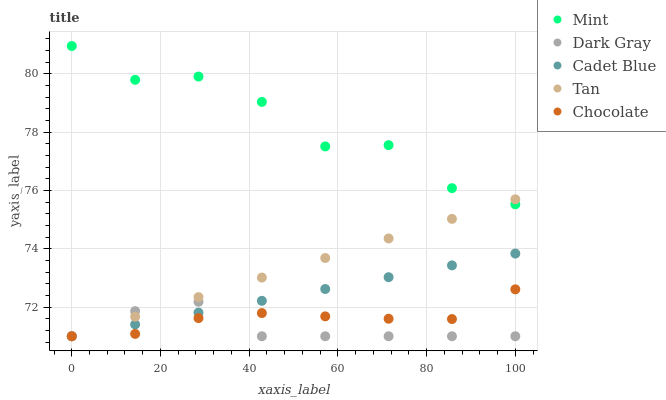Does Dark Gray have the minimum area under the curve?
Answer yes or no. Yes. Does Mint have the maximum area under the curve?
Answer yes or no. Yes. Does Tan have the minimum area under the curve?
Answer yes or no. No. Does Tan have the maximum area under the curve?
Answer yes or no. No. Is Cadet Blue the smoothest?
Answer yes or no. Yes. Is Mint the roughest?
Answer yes or no. Yes. Is Tan the smoothest?
Answer yes or no. No. Is Tan the roughest?
Answer yes or no. No. Does Dark Gray have the lowest value?
Answer yes or no. Yes. Does Mint have the lowest value?
Answer yes or no. No. Does Mint have the highest value?
Answer yes or no. Yes. Does Tan have the highest value?
Answer yes or no. No. Is Chocolate less than Mint?
Answer yes or no. Yes. Is Mint greater than Dark Gray?
Answer yes or no. Yes. Does Dark Gray intersect Tan?
Answer yes or no. Yes. Is Dark Gray less than Tan?
Answer yes or no. No. Is Dark Gray greater than Tan?
Answer yes or no. No. Does Chocolate intersect Mint?
Answer yes or no. No. 